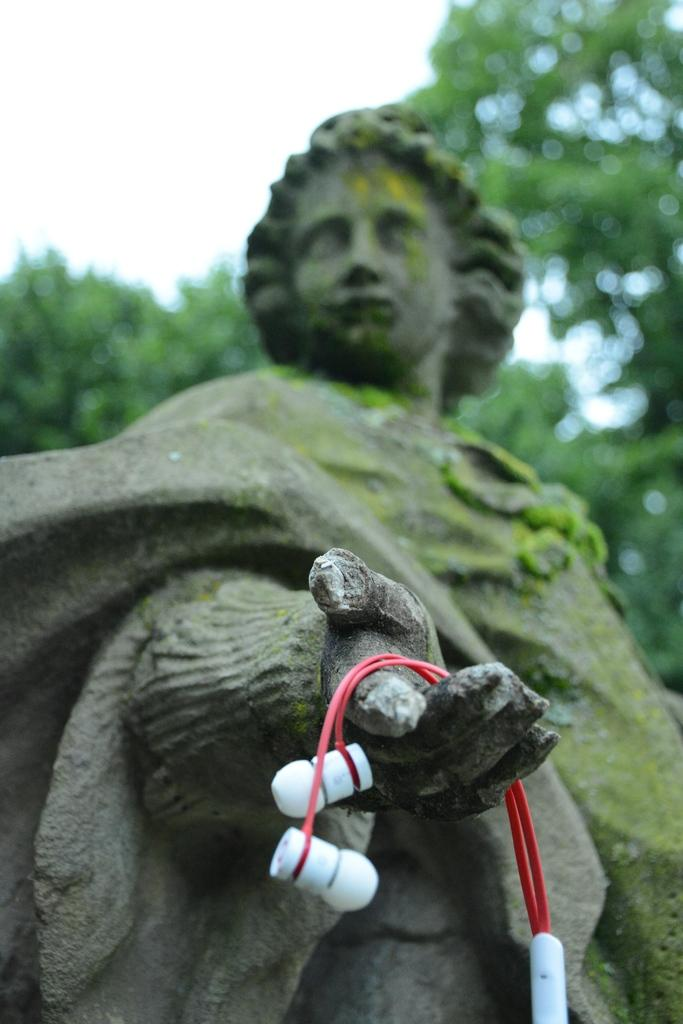What is the main subject in the middle of the image? There is a statue in the middle of the image. What is the statue holding in its hand? The statue has a headset on its hand. What can be seen in the background of the image? There are trees and clouds in the sky in the background of the image. What test is the statue conducting in the image? There is no test being conducted in the image; the statue is simply holding a headset on its hand. What channel is the statue tuning in the image? There is no indication of a channel or any device for tuning in the image; it only features a statue with a headset. 